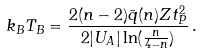<formula> <loc_0><loc_0><loc_500><loc_500>k _ { B } T _ { B } = \frac { 2 ( n - 2 ) \bar { q } ( n ) Z t ^ { 2 } _ { P } } { 2 | U _ { A } | \ln ( \frac { n } { 4 - n } ) } \, .</formula> 